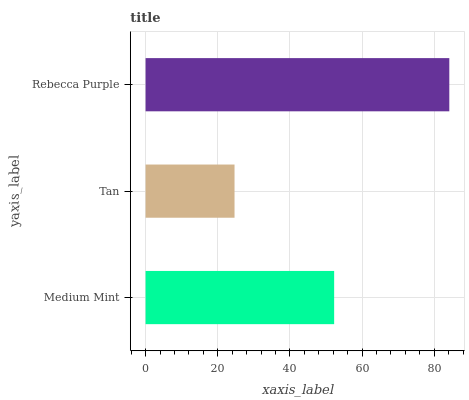Is Tan the minimum?
Answer yes or no. Yes. Is Rebecca Purple the maximum?
Answer yes or no. Yes. Is Rebecca Purple the minimum?
Answer yes or no. No. Is Tan the maximum?
Answer yes or no. No. Is Rebecca Purple greater than Tan?
Answer yes or no. Yes. Is Tan less than Rebecca Purple?
Answer yes or no. Yes. Is Tan greater than Rebecca Purple?
Answer yes or no. No. Is Rebecca Purple less than Tan?
Answer yes or no. No. Is Medium Mint the high median?
Answer yes or no. Yes. Is Medium Mint the low median?
Answer yes or no. Yes. Is Rebecca Purple the high median?
Answer yes or no. No. Is Rebecca Purple the low median?
Answer yes or no. No. 